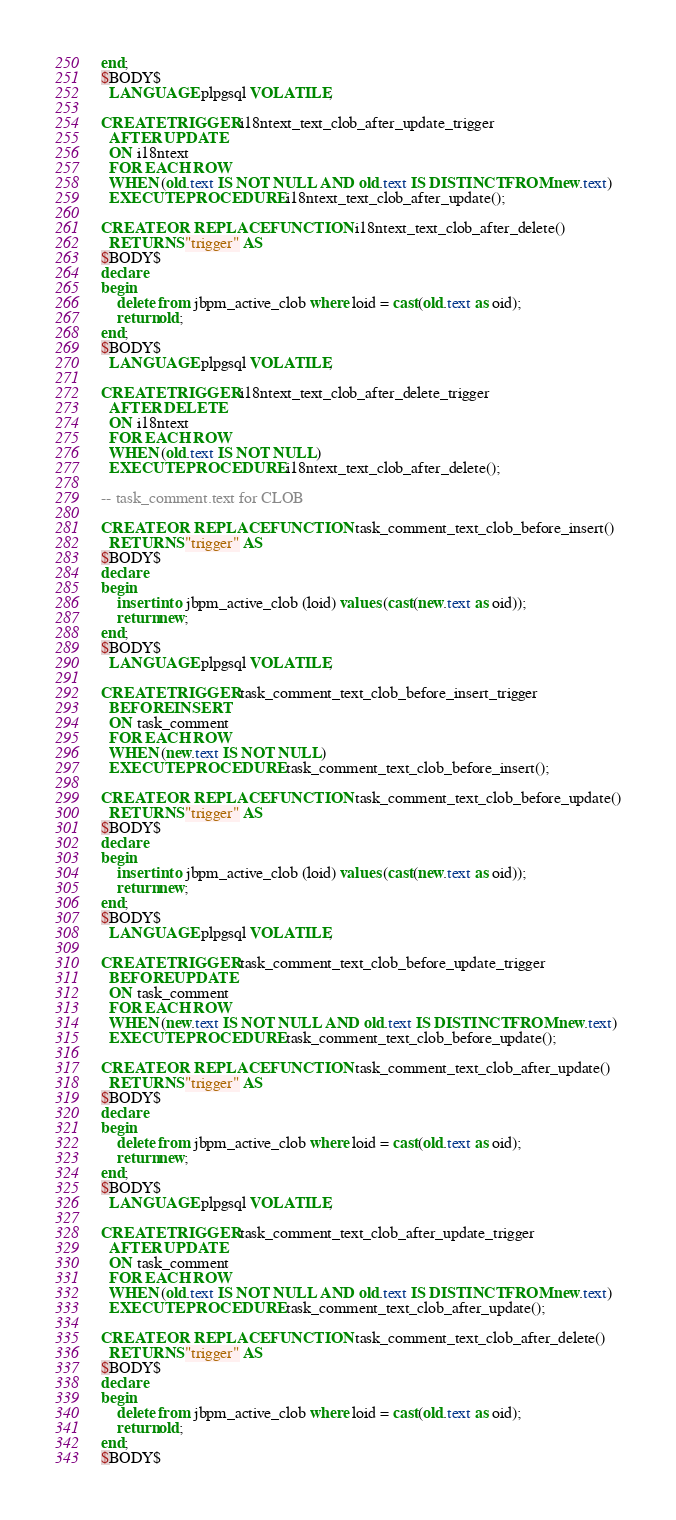<code> <loc_0><loc_0><loc_500><loc_500><_SQL_>end;
$BODY$
  LANGUAGE plpgsql VOLATILE;

CREATE TRIGGER i18ntext_text_clob_after_update_trigger
  AFTER UPDATE
  ON i18ntext
  FOR EACH ROW
  WHEN (old.text IS NOT NULL AND old.text IS DISTINCT FROM new.text)
  EXECUTE PROCEDURE i18ntext_text_clob_after_update();

CREATE OR REPLACE FUNCTION i18ntext_text_clob_after_delete()
  RETURNS "trigger" AS
$BODY$
declare
begin
    delete from jbpm_active_clob where loid = cast(old.text as oid);
    return old;
end;
$BODY$
  LANGUAGE plpgsql VOLATILE;

CREATE TRIGGER i18ntext_text_clob_after_delete_trigger
  AFTER DELETE
  ON i18ntext
  FOR EACH ROW
  WHEN (old.text IS NOT NULL)
  EXECUTE PROCEDURE i18ntext_text_clob_after_delete();

-- task_comment.text for CLOB

CREATE OR REPLACE FUNCTION task_comment_text_clob_before_insert()
  RETURNS "trigger" AS
$BODY$
declare
begin
    insert into jbpm_active_clob (loid) values (cast(new.text as oid));
    return new;
end;
$BODY$
  LANGUAGE plpgsql VOLATILE;

CREATE TRIGGER task_comment_text_clob_before_insert_trigger
  BEFORE INSERT
  ON task_comment
  FOR EACH ROW
  WHEN (new.text IS NOT NULL)
  EXECUTE PROCEDURE task_comment_text_clob_before_insert();

CREATE OR REPLACE FUNCTION task_comment_text_clob_before_update()
  RETURNS "trigger" AS
$BODY$
declare
begin
    insert into jbpm_active_clob (loid) values (cast(new.text as oid));
    return new;
end;
$BODY$
  LANGUAGE plpgsql VOLATILE;

CREATE TRIGGER task_comment_text_clob_before_update_trigger
  BEFORE UPDATE
  ON task_comment
  FOR EACH ROW
  WHEN (new.text IS NOT NULL AND old.text IS DISTINCT FROM new.text)
  EXECUTE PROCEDURE task_comment_text_clob_before_update();

CREATE OR REPLACE FUNCTION task_comment_text_clob_after_update()
  RETURNS "trigger" AS
$BODY$
declare
begin
    delete from jbpm_active_clob where loid = cast(old.text as oid);
    return new;
end;
$BODY$
  LANGUAGE plpgsql VOLATILE;

CREATE TRIGGER task_comment_text_clob_after_update_trigger
  AFTER UPDATE
  ON task_comment
  FOR EACH ROW
  WHEN (old.text IS NOT NULL AND old.text IS DISTINCT FROM new.text)
  EXECUTE PROCEDURE task_comment_text_clob_after_update();

CREATE OR REPLACE FUNCTION task_comment_text_clob_after_delete()
  RETURNS "trigger" AS
$BODY$
declare
begin
    delete from jbpm_active_clob where loid = cast(old.text as oid);
    return old;
end;
$BODY$</code> 